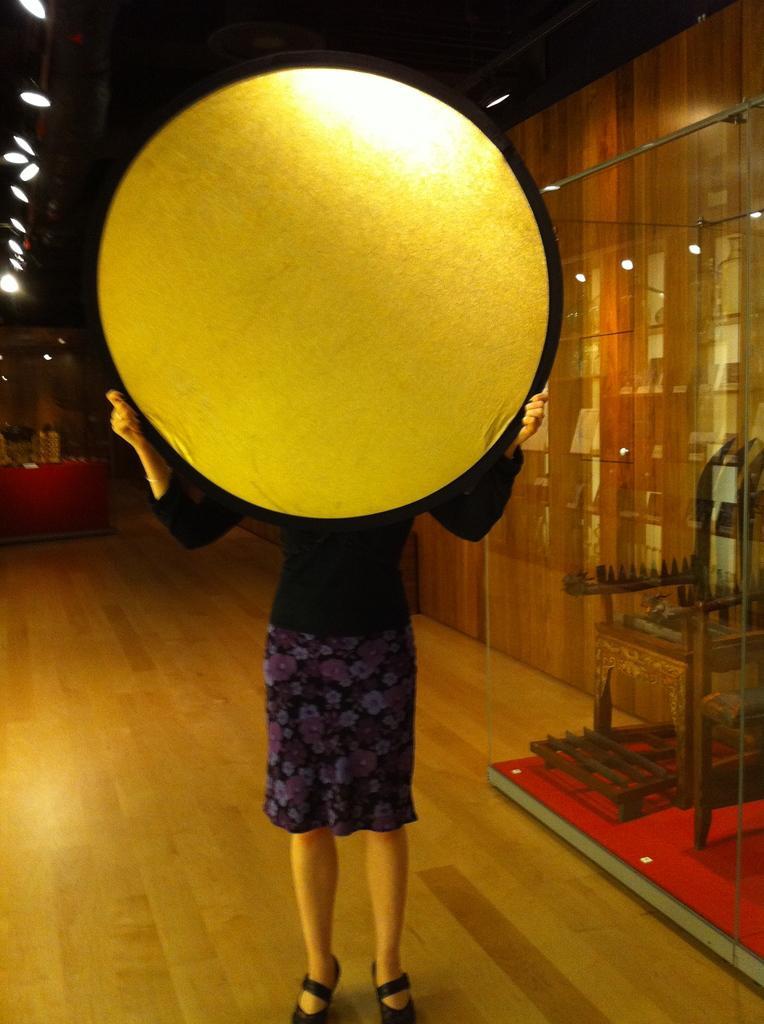Can you describe this image briefly? In the foreground of this image, there is a woman standing on the floor and holding a circular object. In the background, there is a wooden chair inside the glass, wall, lights to the ceiling and few objects on the desk. 